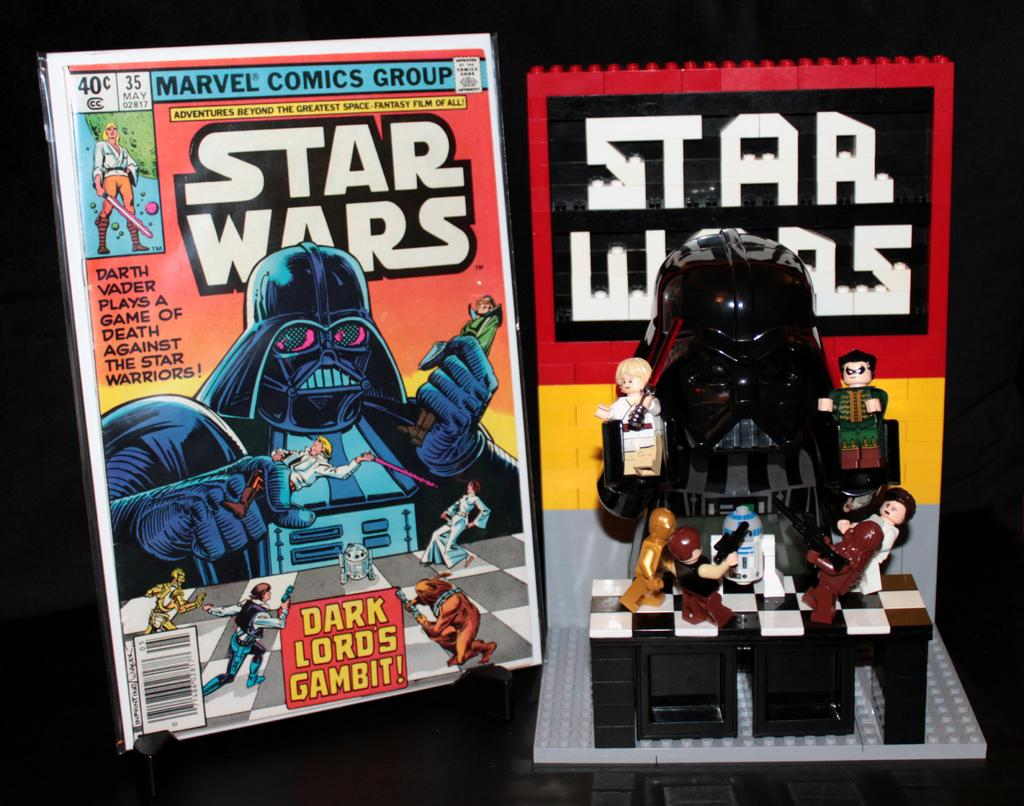What objects are located in the middle of the image? There are toys and books in the middle of the image. Can you describe the types of toys in the image? The provided facts do not specify the types of toys in the image. What can be inferred about the purpose of the books in the image? The presence of books in the image suggests that they might be for reading or learning. Who is teaching the class in the image? There is no class or person present in the image; it only features toys and books. 